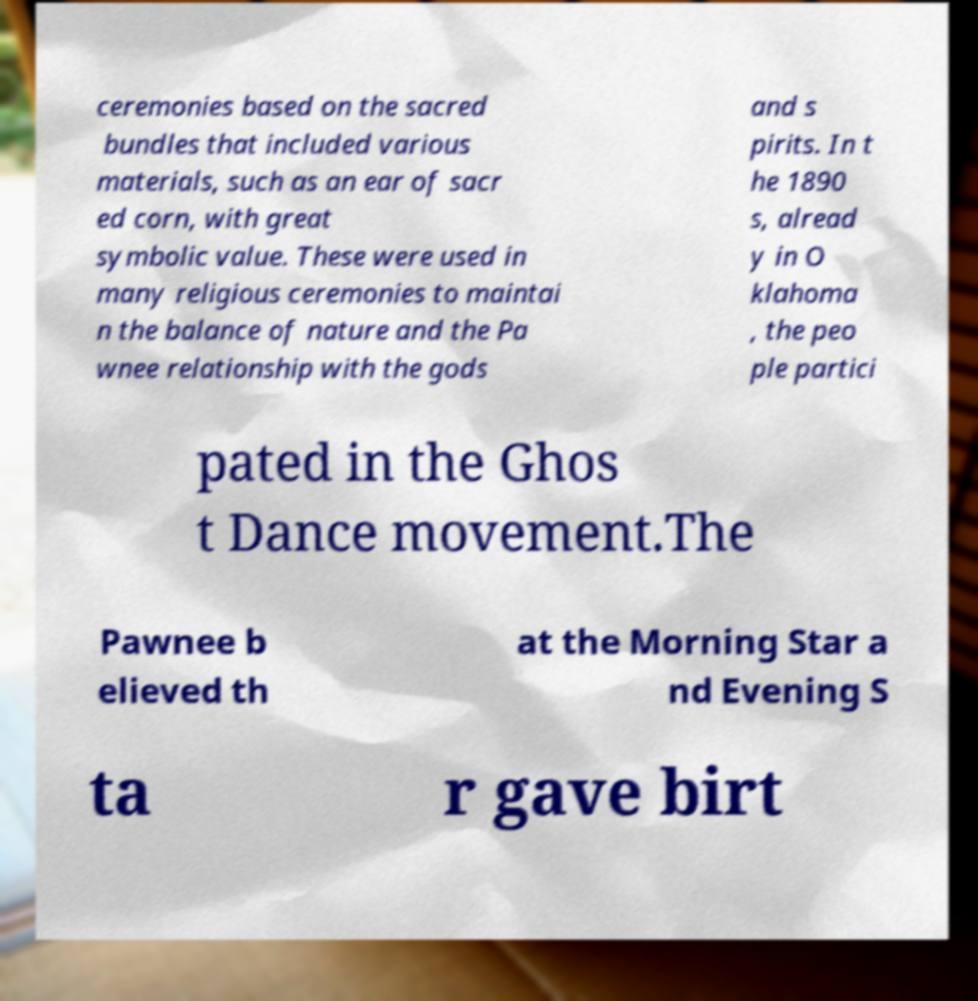Please read and relay the text visible in this image. What does it say? ceremonies based on the sacred bundles that included various materials, such as an ear of sacr ed corn, with great symbolic value. These were used in many religious ceremonies to maintai n the balance of nature and the Pa wnee relationship with the gods and s pirits. In t he 1890 s, alread y in O klahoma , the peo ple partici pated in the Ghos t Dance movement.The Pawnee b elieved th at the Morning Star a nd Evening S ta r gave birt 